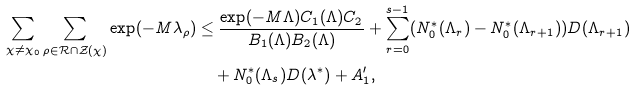<formula> <loc_0><loc_0><loc_500><loc_500>\sum _ { \chi \ne \chi _ { 0 } } \sum _ { \rho \in \mathcal { R } \cap \mathcal { Z } ( \chi ) } \exp ( - M \lambda _ { \rho } ) & \leq \frac { \exp ( - M \Lambda ) C _ { 1 } ( \Lambda ) C _ { 2 } } { B _ { 1 } ( \Lambda ) B _ { 2 } ( \Lambda ) } + \sum _ { r = 0 } ^ { s - 1 } ( N ^ { * } _ { 0 } ( \Lambda _ { r } ) - N ^ { * } _ { 0 } ( \Lambda _ { r + 1 } ) ) D ( \Lambda _ { r + 1 } ) \\ & \quad + N ^ { * } _ { 0 } ( \Lambda _ { s } ) D ( \lambda ^ { * } ) + A _ { 1 } ^ { \prime } ,</formula> 